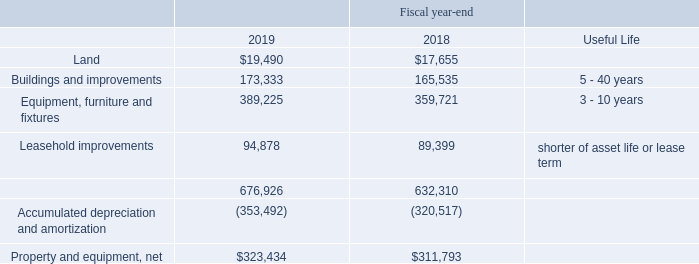Property and Equipment
Property and equipment are stated at cost and are depreciated or amortized using the straight-line method. Cost, accumulated depreciation and amortization, and estimated useful lives are as follows (dollars in thousands):
What is the useful life of Buildings and improvements? 5 - 40 years. How is property and equipment stated in the table? Stated at cost and are depreciated or amortized using the straight-line method. In which years is information on Property and Equipment included in the table? 2019, 2018. In which year was the amount of Land larger? 19,490>17,655
Answer: 2019. What was the change in Leasehold improvements from 2018 to 2019?
Answer scale should be: thousand. 94,878-89,399
Answer: 5479. What was the percentage change in Leasehold improvements from 2018 to 2019?
Answer scale should be: percent. (94,878-89,399)/89,399
Answer: 6.13. 